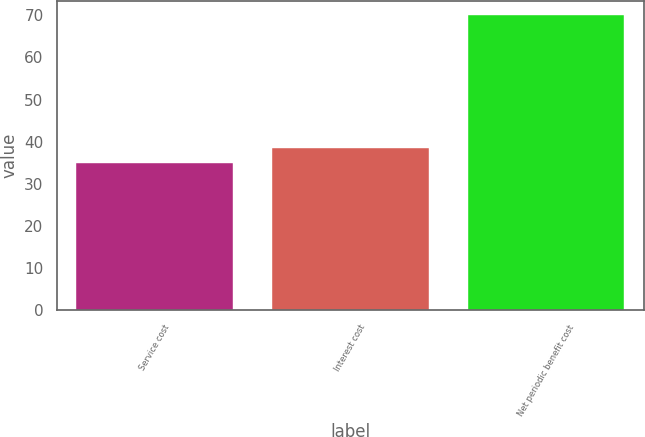Convert chart. <chart><loc_0><loc_0><loc_500><loc_500><bar_chart><fcel>Service cost<fcel>Interest cost<fcel>Net periodic benefit cost<nl><fcel>35<fcel>38.5<fcel>70<nl></chart> 